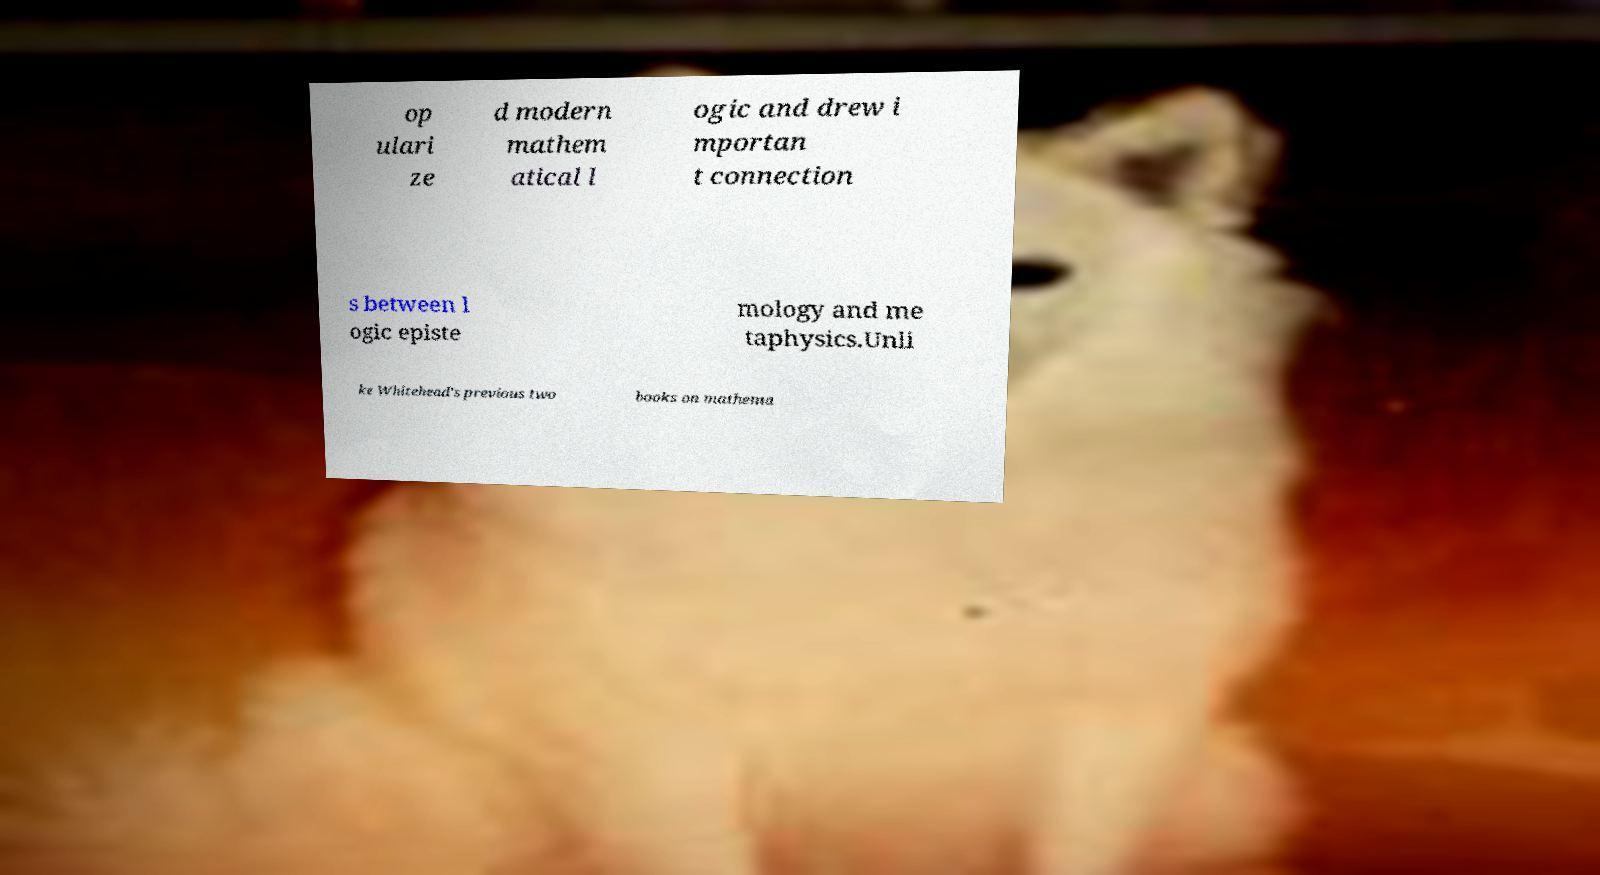Please read and relay the text visible in this image. What does it say? op ulari ze d modern mathem atical l ogic and drew i mportan t connection s between l ogic episte mology and me taphysics.Unli ke Whitehead's previous two books on mathema 